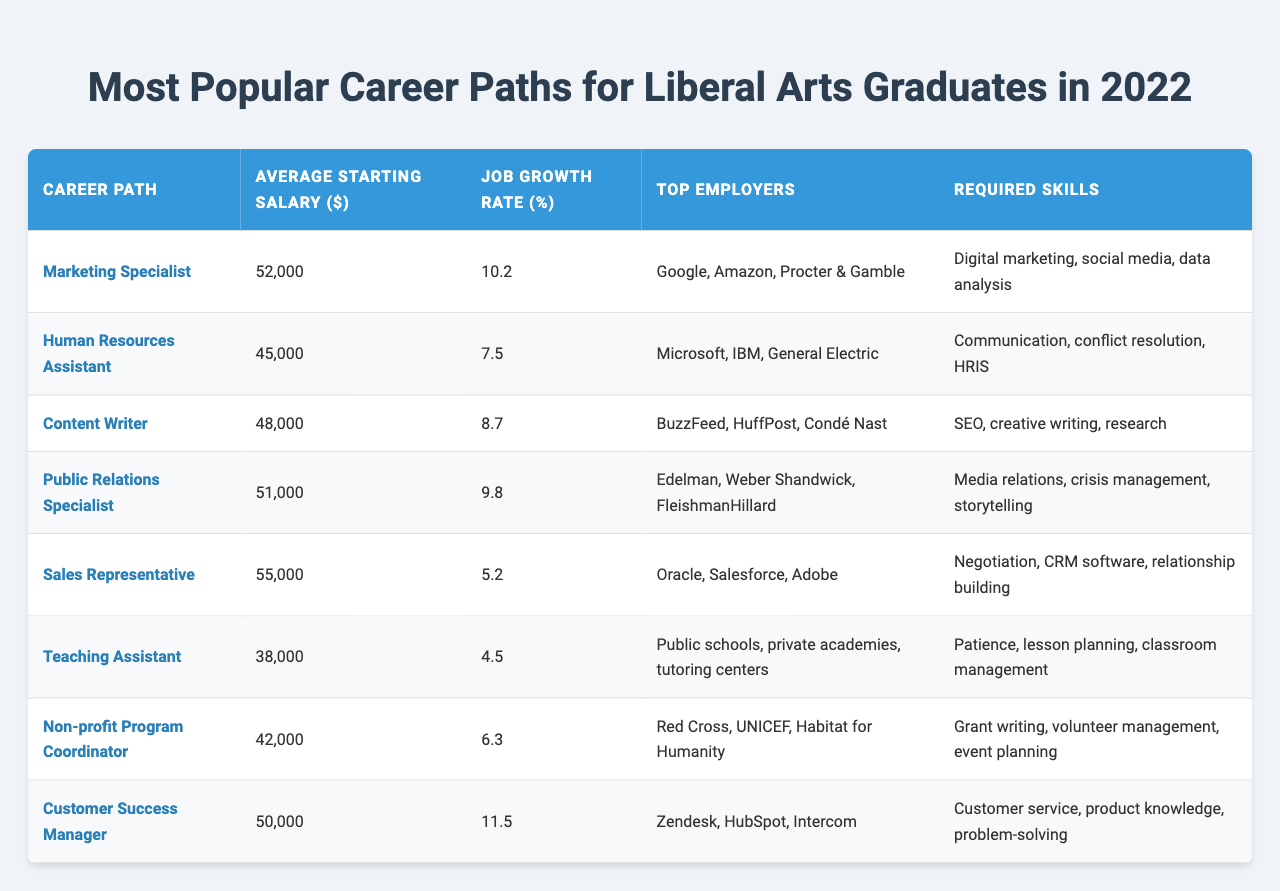What is the average starting salary for a Marketing Specialist? The average starting salary for a Marketing Specialist is listed in the table as $52,000.
Answer: $52,000 Which career path has the highest average starting salary? The career path with the highest average starting salary is Sales Representative at $55,000.
Answer: Sales Representative What percentage job growth rate is expected for a Customer Success Manager? The job growth rate for a Customer Success Manager is 11.5%, as shown in the table.
Answer: 11.5% Is the top employer for Content Writers one of the listed companies? Yes, the table lists BuzzFeed, HuffPost, and Condé Nast as top employers for Content Writers.
Answer: Yes Which career path has the lowest job growth rate, and what is that rate? The career path with the lowest job growth rate is Teaching Assistant, with a rate of 4.5%.
Answer: Teaching Assistant, 4.5% What are the required skills for a Public Relations Specialist? The required skills for a Public Relations Specialist include media relations, crisis management, and storytelling, which are detailed in the table.
Answer: Media relations, crisis management, storytelling Calculate the average starting salary for all the career paths listed. The average starting salary is calculated by adding all salaries: (52000 + 45000 + 48000 + 51000 + 55000 + 38000 + 42000 + 50000) = 386000. Then divide by the number of career paths (8): 386000 / 8 = 48250.
Answer: $48,250 How many career paths listed have a job growth rate higher than 10%? By reviewing the table, we find two career paths with job growth rates higher than 10%: Marketing Specialist (10.2%) and Customer Success Manager (11.5%).
Answer: 2 Which skill is common between a Marketing Specialist and a Customer Success Manager? Both the Marketing Specialist and Customer Success Manager require data analysis or customer service skills, as indicated in their required skills sections.
Answer: Data analysis or customer service If a Human Resources Assistant earns $45,000, what is the difference in salary compared to a Sales Representative? The salary difference is calculated by subtracting the Human Resources Assistant’s salary from the Sales Representative’s salary: $55,000 - $45,000 = $10,000.
Answer: $10,000 